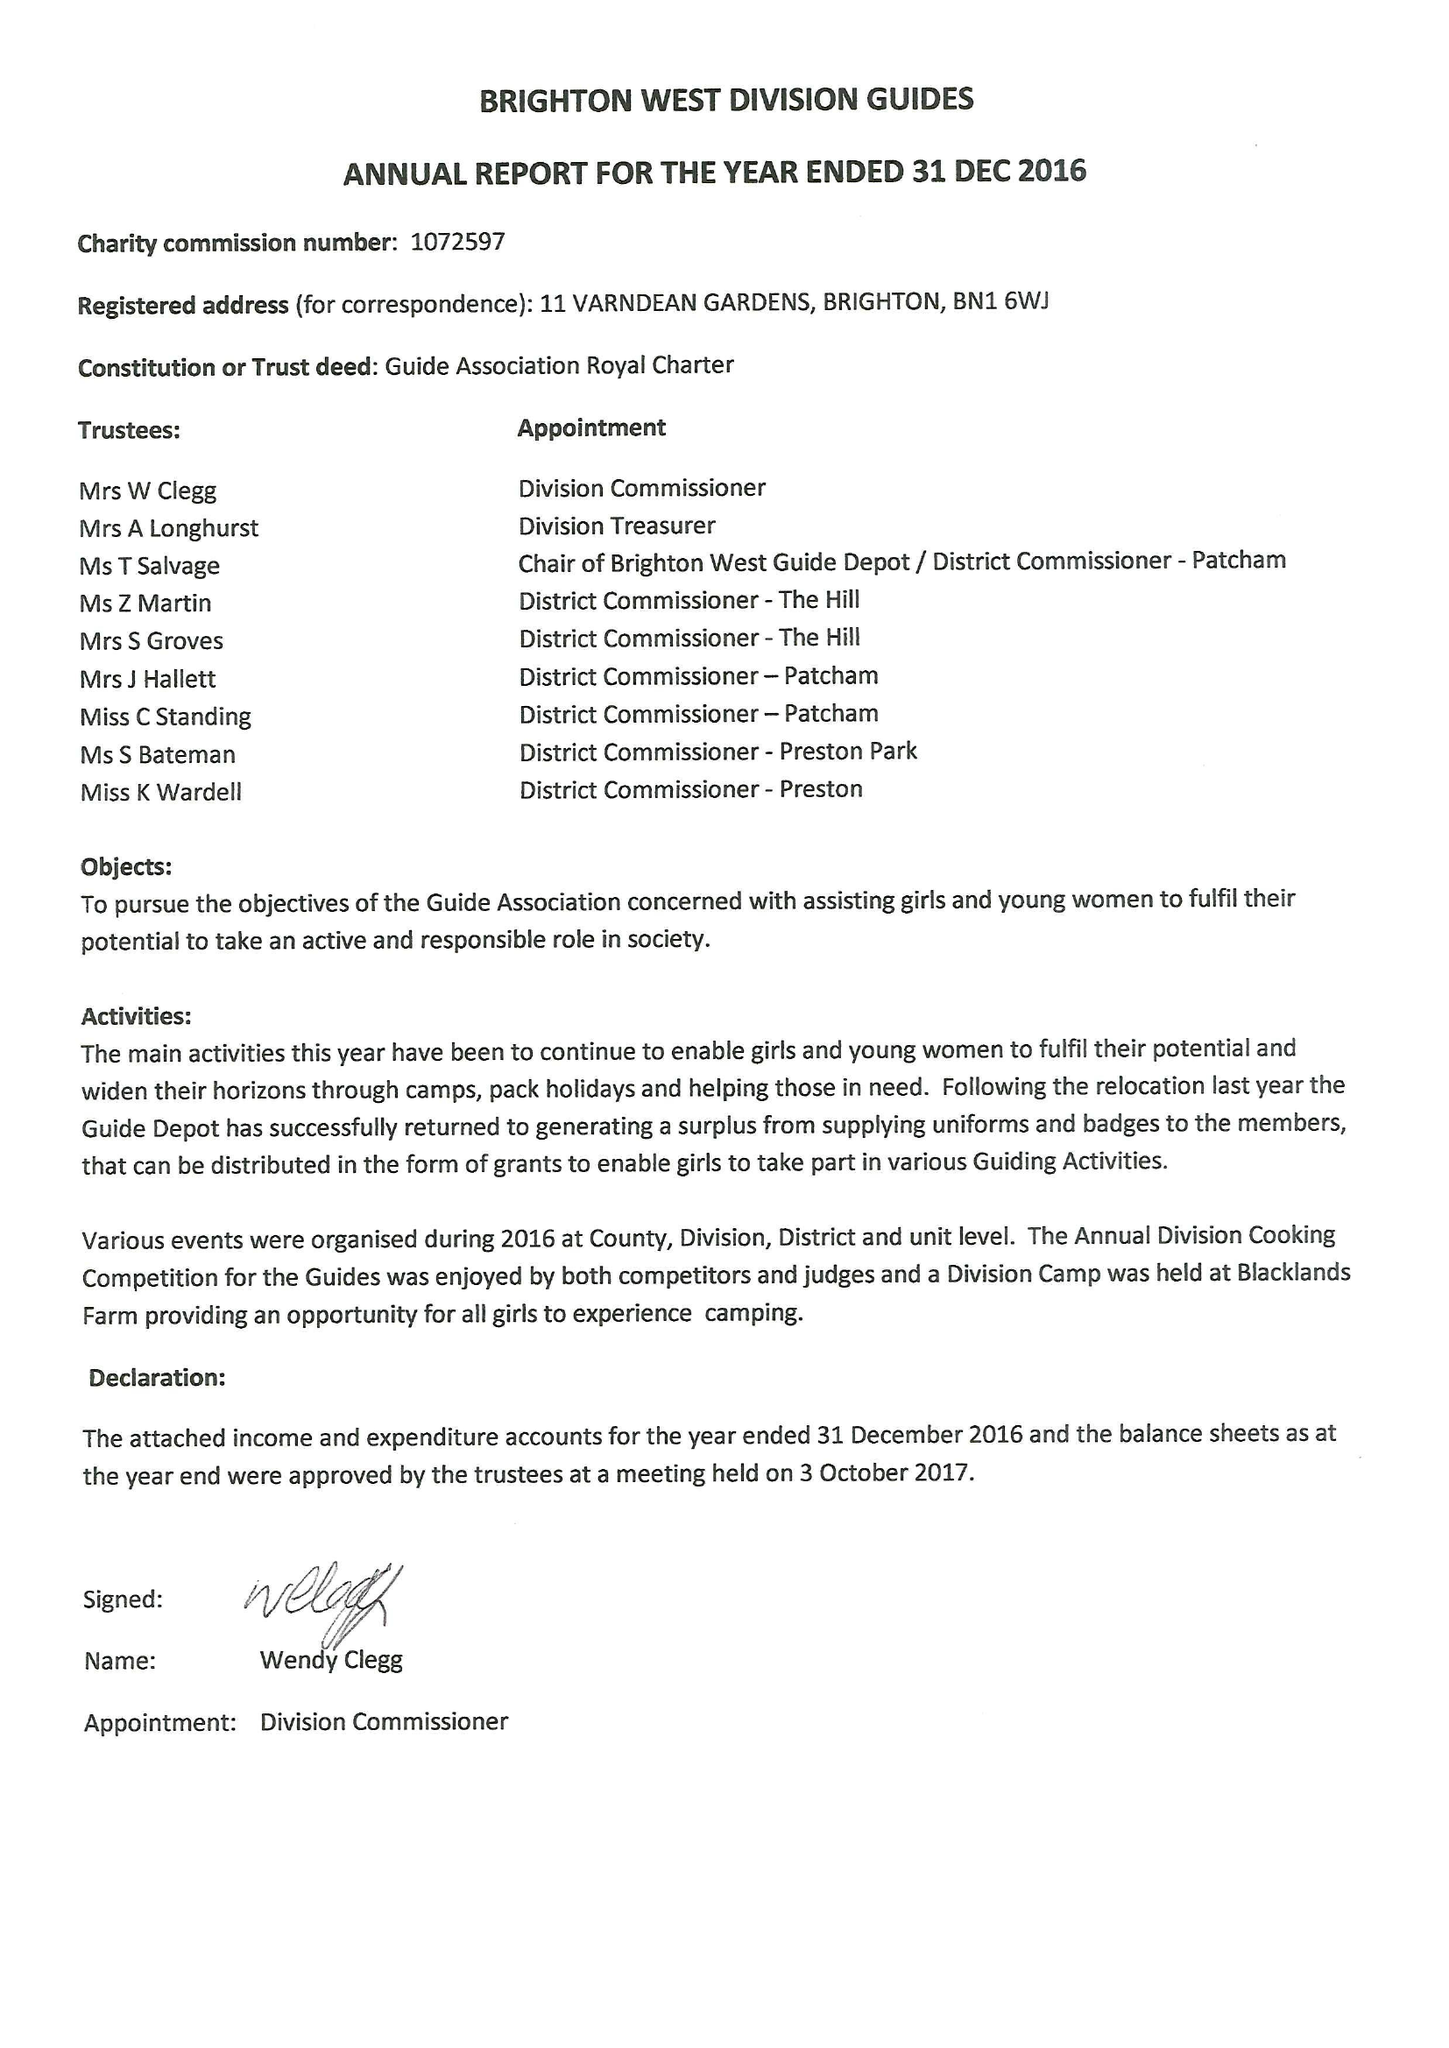What is the value for the income_annually_in_british_pounds?
Answer the question using a single word or phrase. 36599.00 